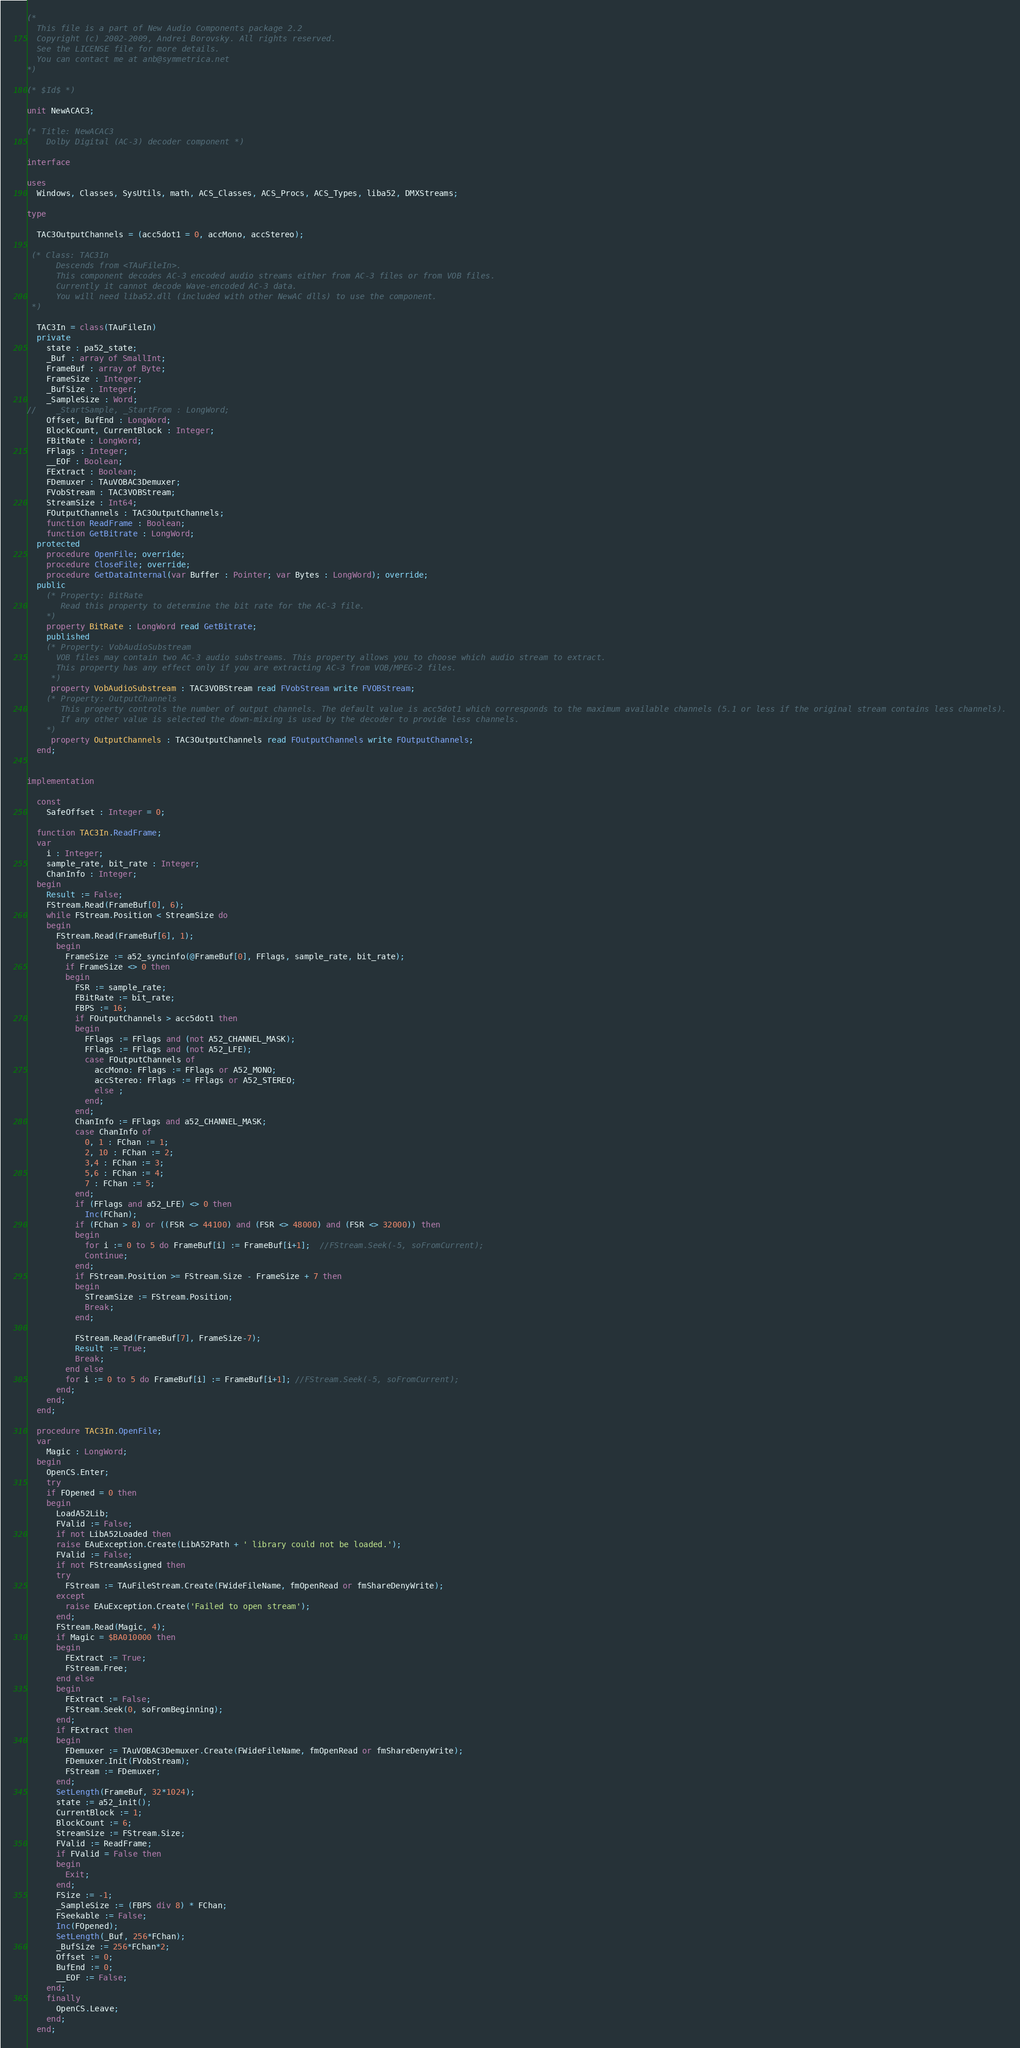Convert code to text. <code><loc_0><loc_0><loc_500><loc_500><_Pascal_>(*
  This file is a part of New Audio Components package 2.2
  Copyright (c) 2002-2009, Andrei Borovsky. All rights reserved.
  See the LICENSE file for more details.
  You can contact me at anb@symmetrica.net
*)

(* $Id$ *)

unit NewACAC3;

(* Title: NewACAC3
    Dolby Digital (AC-3) decoder component *)

interface

uses
  Windows, Classes, SysUtils, math, ACS_Classes, ACS_Procs, ACS_Types, liba52, DMXStreams;

type

  TAC3OutputChannels = (acc5dot1 = 0, accMono, accStereo);

 (* Class: TAC3In
      Descends from <TAuFileIn>.
      This component decodes AC-3 encoded audio streams either from AC-3 files or from VOB files.
      Currently it cannot decode Wave-encoded AC-3 data.
      You will need liba52.dll (included with other NewAC dlls) to use the component.
 *)

  TAC3In = class(TAuFileIn)
  private
    state : pa52_state;
    _Buf : array of SmallInt;
    FrameBuf : array of Byte;
    FrameSize : Integer;
    _BufSize : Integer;
    _SampleSize : Word;
//    _StartSample, _StartFrom : LongWord;
    Offset, BufEnd : LongWord;
    BlockCount, CurrentBlock : Integer;
    FBitRate : LongWord;
    FFlags : Integer;
    __EOF : Boolean;
    FExtract : Boolean;
    FDemuxer : TAuVOBAC3Demuxer;
    FVobStream : TAC3VOBStream;
    StreamSize : Int64;
    FOutputChannels : TAC3OutputChannels;
    function ReadFrame : Boolean;
    function GetBitrate : LongWord;
  protected
    procedure OpenFile; override;
    procedure CloseFile; override;
    procedure GetDataInternal(var Buffer : Pointer; var Bytes : LongWord); override;
  public
    (* Property: BitRate
       Read this property to determine the bit rate for the AC-3 file.
    *)
    property BitRate : LongWord read GetBitrate;
    published
    (* Property: VobAudioSubstream
      VOB files may contain two AC-3 audio substreams. This property allows you to choose which audio stream to extract.
      This property has any effect only if you are extracting AC-3 from VOB/MPEG-2 files.
     *)
     property VobAudioSubstream : TAC3VOBStream read FVobStream write FVOBStream;
    (* Property: OutputChannels
       This property controls the number of output channels. The default value is acc5dot1 which corresponds to the maximum available channels (5.1 or less if the original stream contains less channels).
       If any other value is selected the down-mixing is used by the decoder to provide less channels.
    *)
     property OutputChannels : TAC3OutputChannels read FOutputChannels write FOutputChannels;
  end;


implementation

  const
    SafeOffset : Integer = 0;

  function TAC3In.ReadFrame;
  var
    i : Integer;
    sample_rate, bit_rate : Integer;
    ChanInfo : Integer;
  begin
    Result := False;
    FStream.Read(FrameBuf[0], 6);
    while FStream.Position < StreamSize do
    begin
      FStream.Read(FrameBuf[6], 1);
      begin
        FrameSize := a52_syncinfo(@FrameBuf[0], FFlags, sample_rate, bit_rate);
        if FrameSize <> 0 then
        begin
          FSR := sample_rate;
          FBitRate := bit_rate;
          FBPS := 16;
          if FOutputChannels > acc5dot1 then
          begin
            FFlags := FFlags and (not A52_CHANNEL_MASK);
            FFlags := FFlags and (not A52_LFE);
            case FOutputChannels of
              accMono: FFlags := FFlags or A52_MONO;
              accStereo: FFlags := FFlags or A52_STEREO;
              else ;
            end;
          end;
          ChanInfo := FFlags and a52_CHANNEL_MASK;
          case ChanInfo of
            0, 1 : FChan := 1;
            2, 10 : FChan := 2;
            3,4 : FChan := 3;
            5,6 : FChan := 4;
            7 : FChan := 5;
          end;
          if (FFlags and a52_LFE) <> 0 then
            Inc(FChan);
          if (FChan > 8) or ((FSR <> 44100) and (FSR <> 48000) and (FSR <> 32000)) then
          begin
            for i := 0 to 5 do FrameBuf[i] := FrameBuf[i+1];  //FStream.Seek(-5, soFromCurrent);
            Continue;
          end;
          if FStream.Position >= FStream.Size - FrameSize + 7 then
          begin
            STreamSize := FStream.Position;
            Break;
          end;

          FStream.Read(FrameBuf[7], FrameSize-7);
          Result := True;
          Break;
        end else
        for i := 0 to 5 do FrameBuf[i] := FrameBuf[i+1]; //FStream.Seek(-5, soFromCurrent);
      end;
    end;
  end;

  procedure TAC3In.OpenFile;
  var
    Magic : LongWord;
  begin
    OpenCS.Enter;
    try
    if FOpened = 0 then
    begin
      LoadA52Lib;
      FValid := False;
      if not LibA52Loaded then
      raise EAuException.Create(LibA52Path + ' library could not be loaded.');
      FValid := False;
      if not FStreamAssigned then
      try
        FStream := TAuFileStream.Create(FWideFileName, fmOpenRead or fmShareDenyWrite);
      except
        raise EAuException.Create('Failed to open stream');
      end;
      FStream.Read(Magic, 4);
      if Magic = $BA010000 then
      begin
        FExtract := True;
        FStream.Free;
      end else
      begin
        FExtract := False;
        FStream.Seek(0, soFromBeginning);
      end;
      if FExtract then
      begin
        FDemuxer := TAuVOBAC3Demuxer.Create(FWideFileName, fmOpenRead or fmShareDenyWrite);
        FDemuxer.Init(FVobStream);
        FStream := FDemuxer;
      end;
      SetLength(FrameBuf, 32*1024);
      state := a52_init();
      CurrentBlock := 1;
      BlockCount := 6;
      StreamSize := FStream.Size;
      FValid := ReadFrame;
      if FValid = False then
      begin
        Exit;
      end;
      FSize := -1;
      _SampleSize := (FBPS div 8) * FChan;
      FSeekable := False;
      Inc(FOpened);
      SetLength(_Buf, 256*FChan);
      _BufSize := 256*FChan*2;
      Offset := 0;
      BufEnd := 0;
      __EOF := False;
    end;
    finally
      OpenCS.Leave;
    end;
  end;
</code> 